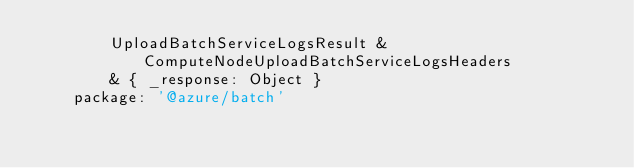Convert code to text. <code><loc_0><loc_0><loc_500><loc_500><_YAML_>        UploadBatchServiceLogsResult & ComputeNodeUploadBatchServiceLogsHeaders
        & { _response: Object }
    package: '@azure/batch'
</code> 